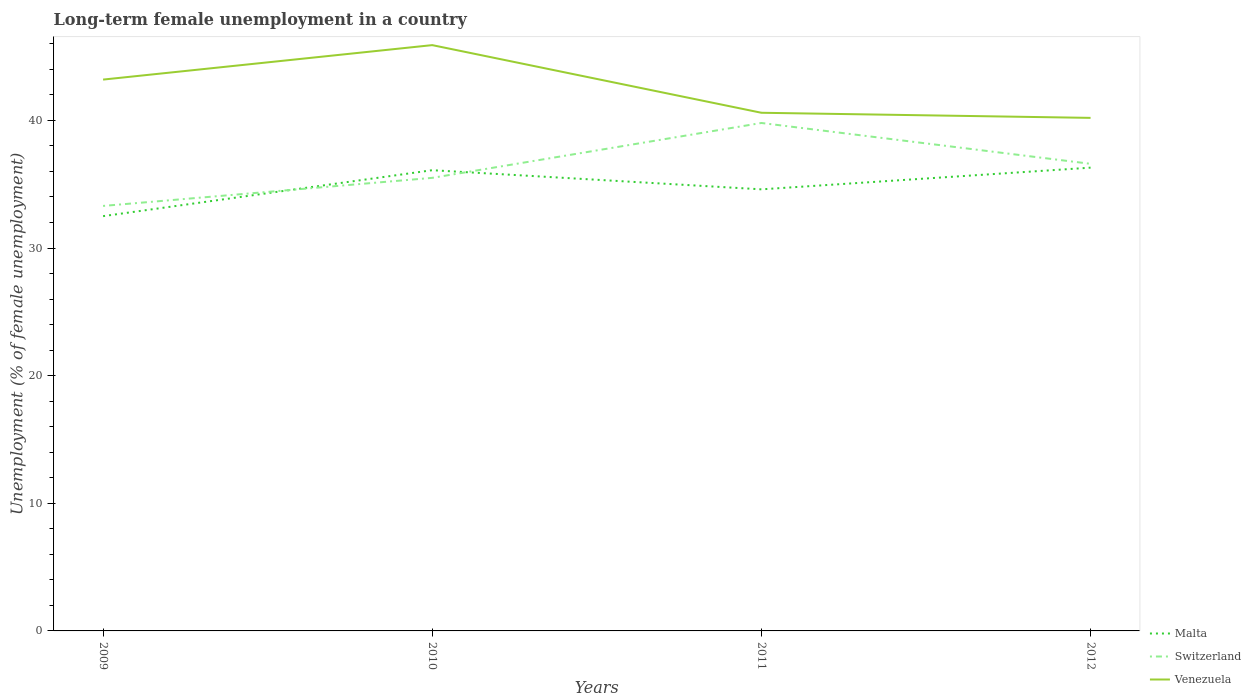Does the line corresponding to Venezuela intersect with the line corresponding to Switzerland?
Offer a very short reply. No. Across all years, what is the maximum percentage of long-term unemployed female population in Venezuela?
Give a very brief answer. 40.2. In which year was the percentage of long-term unemployed female population in Venezuela maximum?
Your answer should be compact. 2012. What is the total percentage of long-term unemployed female population in Malta in the graph?
Provide a succinct answer. -3.8. What is the difference between the highest and the second highest percentage of long-term unemployed female population in Malta?
Keep it short and to the point. 3.8. Is the percentage of long-term unemployed female population in Switzerland strictly greater than the percentage of long-term unemployed female population in Malta over the years?
Your answer should be very brief. No. How many lines are there?
Your response must be concise. 3. How many years are there in the graph?
Offer a very short reply. 4. Are the values on the major ticks of Y-axis written in scientific E-notation?
Provide a succinct answer. No. Does the graph contain any zero values?
Your answer should be compact. No. Does the graph contain grids?
Your answer should be compact. No. Where does the legend appear in the graph?
Keep it short and to the point. Bottom right. How many legend labels are there?
Your answer should be compact. 3. What is the title of the graph?
Provide a succinct answer. Long-term female unemployment in a country. Does "Eritrea" appear as one of the legend labels in the graph?
Provide a succinct answer. No. What is the label or title of the Y-axis?
Your response must be concise. Unemployment (% of female unemployment). What is the Unemployment (% of female unemployment) in Malta in 2009?
Keep it short and to the point. 32.5. What is the Unemployment (% of female unemployment) in Switzerland in 2009?
Your response must be concise. 33.3. What is the Unemployment (% of female unemployment) in Venezuela in 2009?
Provide a short and direct response. 43.2. What is the Unemployment (% of female unemployment) in Malta in 2010?
Your answer should be very brief. 36.1. What is the Unemployment (% of female unemployment) in Switzerland in 2010?
Offer a terse response. 35.5. What is the Unemployment (% of female unemployment) of Venezuela in 2010?
Give a very brief answer. 45.9. What is the Unemployment (% of female unemployment) of Malta in 2011?
Your response must be concise. 34.6. What is the Unemployment (% of female unemployment) of Switzerland in 2011?
Your answer should be very brief. 39.8. What is the Unemployment (% of female unemployment) in Venezuela in 2011?
Provide a succinct answer. 40.6. What is the Unemployment (% of female unemployment) of Malta in 2012?
Make the answer very short. 36.3. What is the Unemployment (% of female unemployment) of Switzerland in 2012?
Give a very brief answer. 36.6. What is the Unemployment (% of female unemployment) of Venezuela in 2012?
Give a very brief answer. 40.2. Across all years, what is the maximum Unemployment (% of female unemployment) of Malta?
Ensure brevity in your answer.  36.3. Across all years, what is the maximum Unemployment (% of female unemployment) of Switzerland?
Give a very brief answer. 39.8. Across all years, what is the maximum Unemployment (% of female unemployment) of Venezuela?
Give a very brief answer. 45.9. Across all years, what is the minimum Unemployment (% of female unemployment) in Malta?
Offer a terse response. 32.5. Across all years, what is the minimum Unemployment (% of female unemployment) in Switzerland?
Provide a short and direct response. 33.3. Across all years, what is the minimum Unemployment (% of female unemployment) of Venezuela?
Make the answer very short. 40.2. What is the total Unemployment (% of female unemployment) in Malta in the graph?
Your answer should be compact. 139.5. What is the total Unemployment (% of female unemployment) in Switzerland in the graph?
Give a very brief answer. 145.2. What is the total Unemployment (% of female unemployment) in Venezuela in the graph?
Provide a short and direct response. 169.9. What is the difference between the Unemployment (% of female unemployment) of Malta in 2009 and that in 2010?
Keep it short and to the point. -3.6. What is the difference between the Unemployment (% of female unemployment) of Switzerland in 2009 and that in 2011?
Offer a terse response. -6.5. What is the difference between the Unemployment (% of female unemployment) in Malta in 2009 and that in 2012?
Offer a very short reply. -3.8. What is the difference between the Unemployment (% of female unemployment) in Switzerland in 2009 and that in 2012?
Offer a terse response. -3.3. What is the difference between the Unemployment (% of female unemployment) in Switzerland in 2010 and that in 2011?
Your answer should be very brief. -4.3. What is the difference between the Unemployment (% of female unemployment) in Malta in 2010 and that in 2012?
Provide a short and direct response. -0.2. What is the difference between the Unemployment (% of female unemployment) of Venezuela in 2010 and that in 2012?
Offer a very short reply. 5.7. What is the difference between the Unemployment (% of female unemployment) in Malta in 2009 and the Unemployment (% of female unemployment) in Switzerland in 2010?
Provide a succinct answer. -3. What is the difference between the Unemployment (% of female unemployment) in Malta in 2009 and the Unemployment (% of female unemployment) in Venezuela in 2010?
Give a very brief answer. -13.4. What is the difference between the Unemployment (% of female unemployment) in Malta in 2009 and the Unemployment (% of female unemployment) in Switzerland in 2011?
Provide a succinct answer. -7.3. What is the difference between the Unemployment (% of female unemployment) of Malta in 2009 and the Unemployment (% of female unemployment) of Switzerland in 2012?
Your answer should be compact. -4.1. What is the difference between the Unemployment (% of female unemployment) of Malta in 2009 and the Unemployment (% of female unemployment) of Venezuela in 2012?
Your answer should be compact. -7.7. What is the difference between the Unemployment (% of female unemployment) of Switzerland in 2009 and the Unemployment (% of female unemployment) of Venezuela in 2012?
Offer a terse response. -6.9. What is the difference between the Unemployment (% of female unemployment) in Malta in 2010 and the Unemployment (% of female unemployment) in Switzerland in 2012?
Your response must be concise. -0.5. What is the difference between the Unemployment (% of female unemployment) in Malta in 2010 and the Unemployment (% of female unemployment) in Venezuela in 2012?
Your response must be concise. -4.1. What is the difference between the Unemployment (% of female unemployment) of Malta in 2011 and the Unemployment (% of female unemployment) of Venezuela in 2012?
Your answer should be very brief. -5.6. What is the average Unemployment (% of female unemployment) in Malta per year?
Provide a succinct answer. 34.88. What is the average Unemployment (% of female unemployment) of Switzerland per year?
Your answer should be compact. 36.3. What is the average Unemployment (% of female unemployment) in Venezuela per year?
Ensure brevity in your answer.  42.48. In the year 2009, what is the difference between the Unemployment (% of female unemployment) in Malta and Unemployment (% of female unemployment) in Venezuela?
Your answer should be compact. -10.7. In the year 2010, what is the difference between the Unemployment (% of female unemployment) of Malta and Unemployment (% of female unemployment) of Switzerland?
Your answer should be very brief. 0.6. In the year 2010, what is the difference between the Unemployment (% of female unemployment) of Switzerland and Unemployment (% of female unemployment) of Venezuela?
Your answer should be compact. -10.4. In the year 2011, what is the difference between the Unemployment (% of female unemployment) of Malta and Unemployment (% of female unemployment) of Switzerland?
Provide a succinct answer. -5.2. In the year 2011, what is the difference between the Unemployment (% of female unemployment) in Switzerland and Unemployment (% of female unemployment) in Venezuela?
Offer a very short reply. -0.8. In the year 2012, what is the difference between the Unemployment (% of female unemployment) in Malta and Unemployment (% of female unemployment) in Venezuela?
Provide a succinct answer. -3.9. What is the ratio of the Unemployment (% of female unemployment) in Malta in 2009 to that in 2010?
Provide a succinct answer. 0.9. What is the ratio of the Unemployment (% of female unemployment) of Switzerland in 2009 to that in 2010?
Your response must be concise. 0.94. What is the ratio of the Unemployment (% of female unemployment) in Malta in 2009 to that in 2011?
Ensure brevity in your answer.  0.94. What is the ratio of the Unemployment (% of female unemployment) of Switzerland in 2009 to that in 2011?
Your answer should be compact. 0.84. What is the ratio of the Unemployment (% of female unemployment) in Venezuela in 2009 to that in 2011?
Offer a terse response. 1.06. What is the ratio of the Unemployment (% of female unemployment) of Malta in 2009 to that in 2012?
Offer a very short reply. 0.9. What is the ratio of the Unemployment (% of female unemployment) in Switzerland in 2009 to that in 2012?
Ensure brevity in your answer.  0.91. What is the ratio of the Unemployment (% of female unemployment) of Venezuela in 2009 to that in 2012?
Give a very brief answer. 1.07. What is the ratio of the Unemployment (% of female unemployment) of Malta in 2010 to that in 2011?
Offer a terse response. 1.04. What is the ratio of the Unemployment (% of female unemployment) of Switzerland in 2010 to that in 2011?
Keep it short and to the point. 0.89. What is the ratio of the Unemployment (% of female unemployment) in Venezuela in 2010 to that in 2011?
Provide a short and direct response. 1.13. What is the ratio of the Unemployment (% of female unemployment) of Malta in 2010 to that in 2012?
Ensure brevity in your answer.  0.99. What is the ratio of the Unemployment (% of female unemployment) in Switzerland in 2010 to that in 2012?
Provide a short and direct response. 0.97. What is the ratio of the Unemployment (% of female unemployment) of Venezuela in 2010 to that in 2012?
Provide a short and direct response. 1.14. What is the ratio of the Unemployment (% of female unemployment) of Malta in 2011 to that in 2012?
Your response must be concise. 0.95. What is the ratio of the Unemployment (% of female unemployment) of Switzerland in 2011 to that in 2012?
Your response must be concise. 1.09. What is the ratio of the Unemployment (% of female unemployment) in Venezuela in 2011 to that in 2012?
Provide a succinct answer. 1.01. What is the difference between the highest and the second highest Unemployment (% of female unemployment) of Venezuela?
Provide a short and direct response. 2.7. What is the difference between the highest and the lowest Unemployment (% of female unemployment) in Malta?
Your response must be concise. 3.8. What is the difference between the highest and the lowest Unemployment (% of female unemployment) in Switzerland?
Ensure brevity in your answer.  6.5. What is the difference between the highest and the lowest Unemployment (% of female unemployment) of Venezuela?
Offer a very short reply. 5.7. 